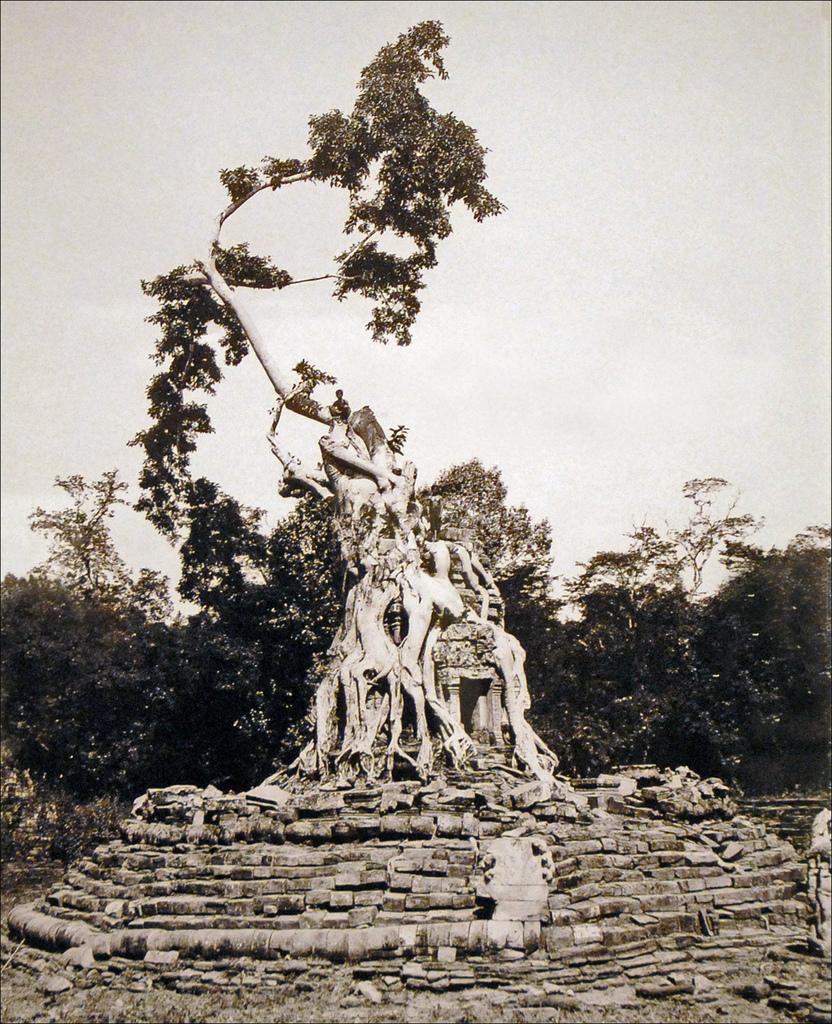Please provide a concise description of this image. In this picture there is a tree on the building and there is a person sitting on the tree. At the back there are trees. At the top there is sky. In the foreground there are steps. 